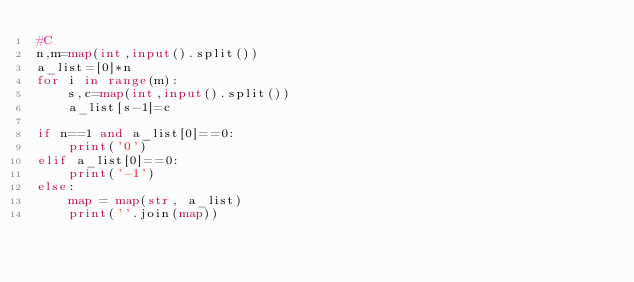<code> <loc_0><loc_0><loc_500><loc_500><_Python_>#C
n,m=map(int,input().split())
a_list=[0]*n
for i in range(m):
    s,c=map(int,input().split())
    a_list[s-1]=c

if n==1 and a_list[0]==0:
    print('0')
elif a_list[0]==0:
    print('-1')
else:
    map = map(str, a_list)
    print(''.join(map))</code> 